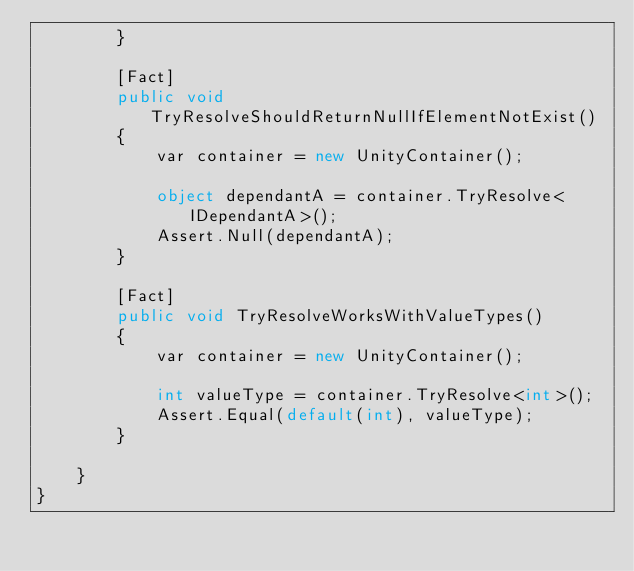<code> <loc_0><loc_0><loc_500><loc_500><_C#_>        }

        [Fact]
        public void TryResolveShouldReturnNullIfElementNotExist()
        {
            var container = new UnityContainer();

            object dependantA = container.TryResolve<IDependantA>();
            Assert.Null(dependantA);
        }

        [Fact]
        public void TryResolveWorksWithValueTypes()
        {
            var container = new UnityContainer();

            int valueType = container.TryResolve<int>();
            Assert.Equal(default(int), valueType);
        }

    }
}</code> 